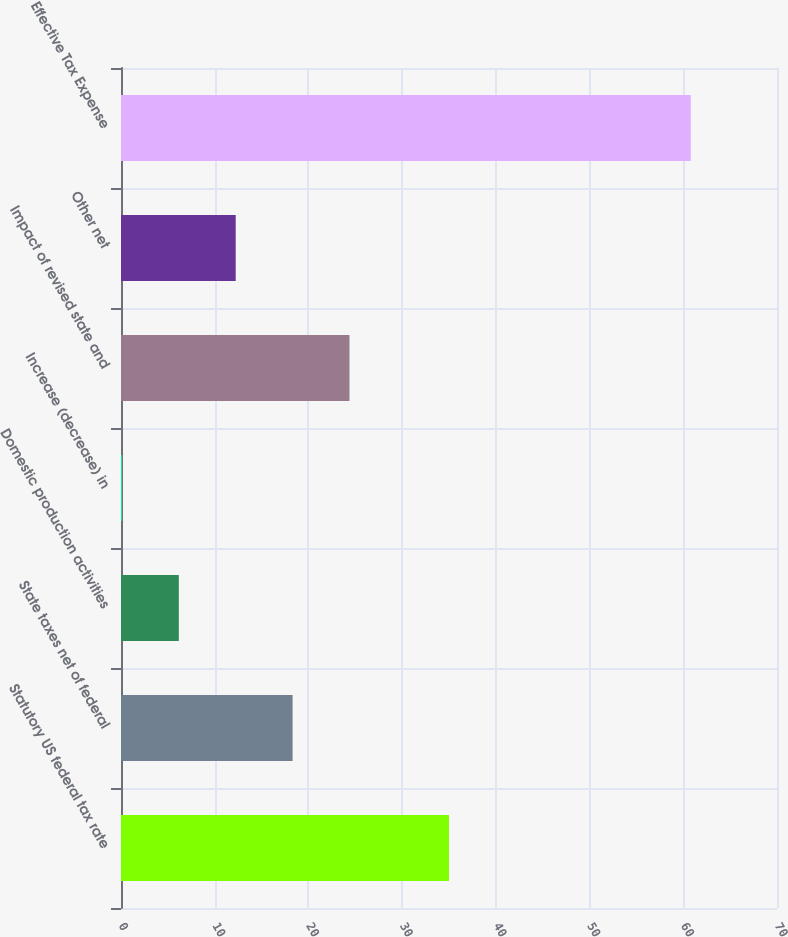Convert chart to OTSL. <chart><loc_0><loc_0><loc_500><loc_500><bar_chart><fcel>Statutory US federal tax rate<fcel>State taxes net of federal<fcel>Domestic production activities<fcel>Increase (decrease) in<fcel>Impact of revised state and<fcel>Other net<fcel>Effective Tax Expense<nl><fcel>35<fcel>18.31<fcel>6.17<fcel>0.1<fcel>24.38<fcel>12.24<fcel>60.8<nl></chart> 